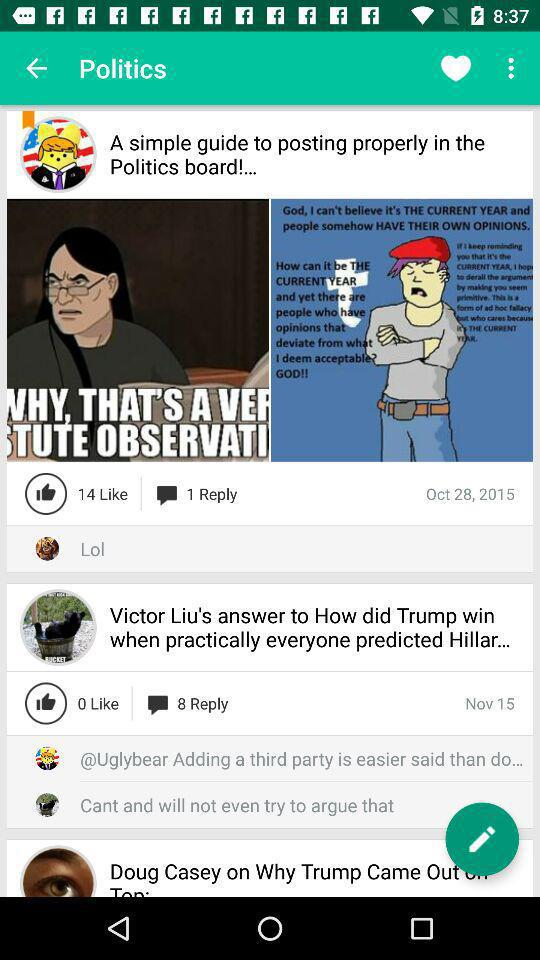How many likes does "Victor Liu's answer to How did Trump win when practically everyone predicted Hillar..." post get? The post "Victor Liu's answer to How did Trump win when practically everyone predicted Hillar..." gets 0 likes. 